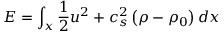Convert formula to latex. <formula><loc_0><loc_0><loc_500><loc_500>E = \int _ { x } \frac { 1 } { 2 } u ^ { 2 } + c _ { s } ^ { 2 } \left ( \rho - \rho _ { 0 } \right ) d x</formula> 